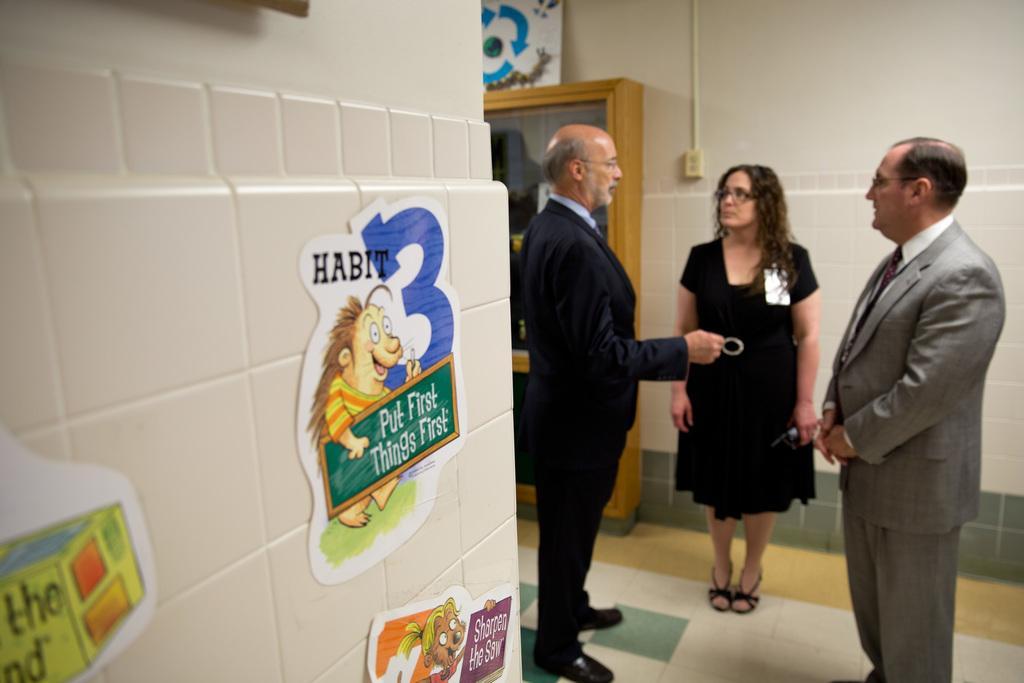Could you give a brief overview of what you see in this image? In the picture we can see three people are standing on the floor, two are men and one woman, woman are wearing black dress and men are wearing blazers, ties and shirts and they are talking something and beside them, we can see a wall with tiles to it with some stickers pasted to it and behind them we can see a wall with a cupboard and top of it we can see some white color board and some painting on it. 